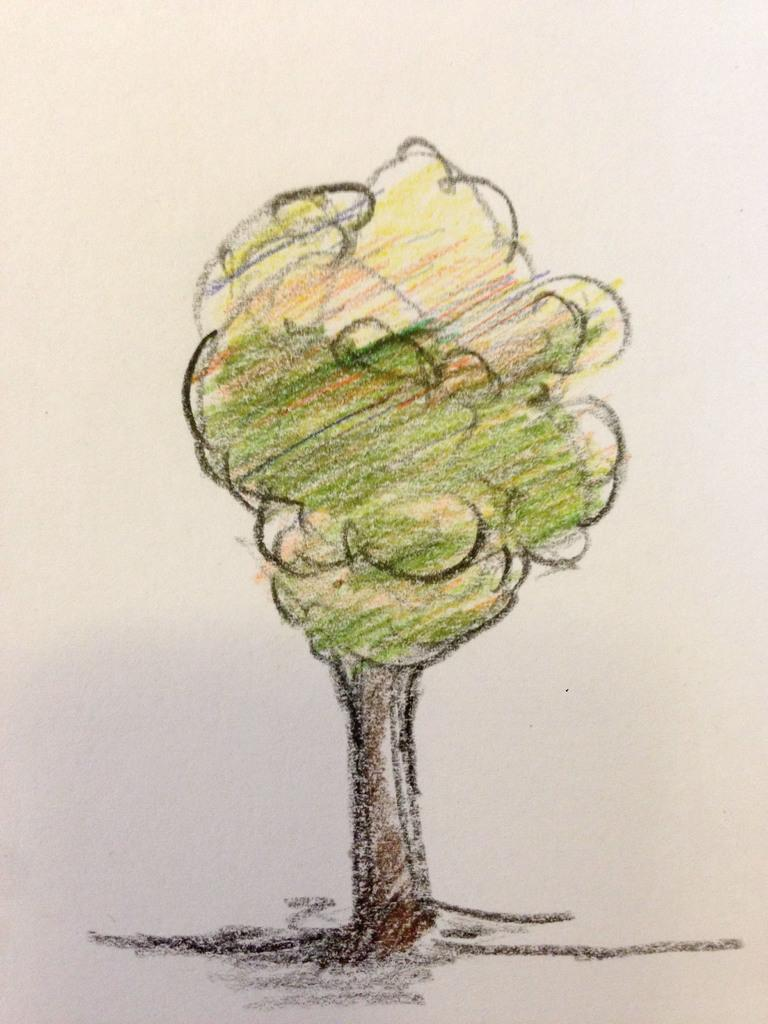What is depicted on the paper in the image? A tree is drawn on the paper in the image. How was the tree colored on the paper? The tree is colored with crayons. What type of pie is being served at the discussion in the image? There is no discussion or pie present in the image; it only features a paper with a colored tree drawing. 